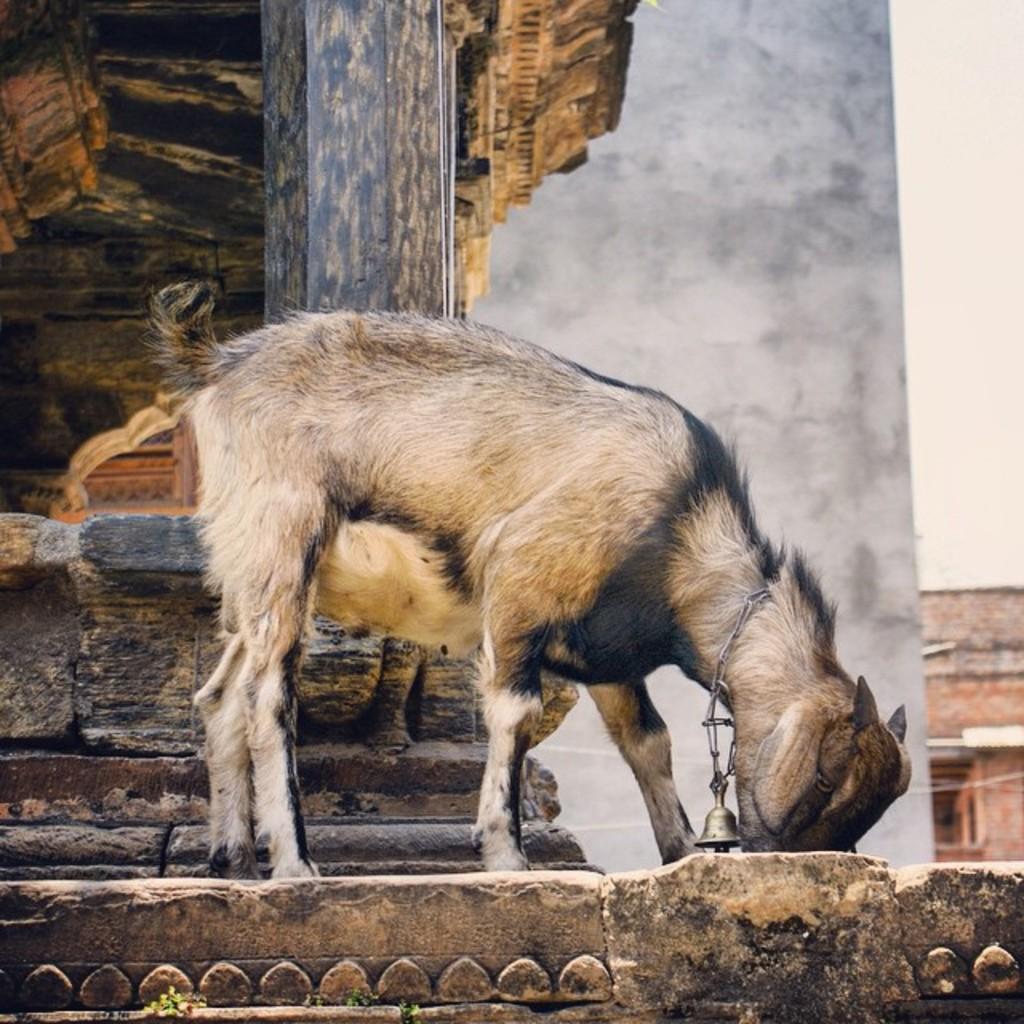How would you summarize this image in a sentence or two? This image consists of a road. To its neck there is a bell tied. To the left, there is a building ,made up of rock. In the background, there is a wall in white color. To the top right, there is sky. 